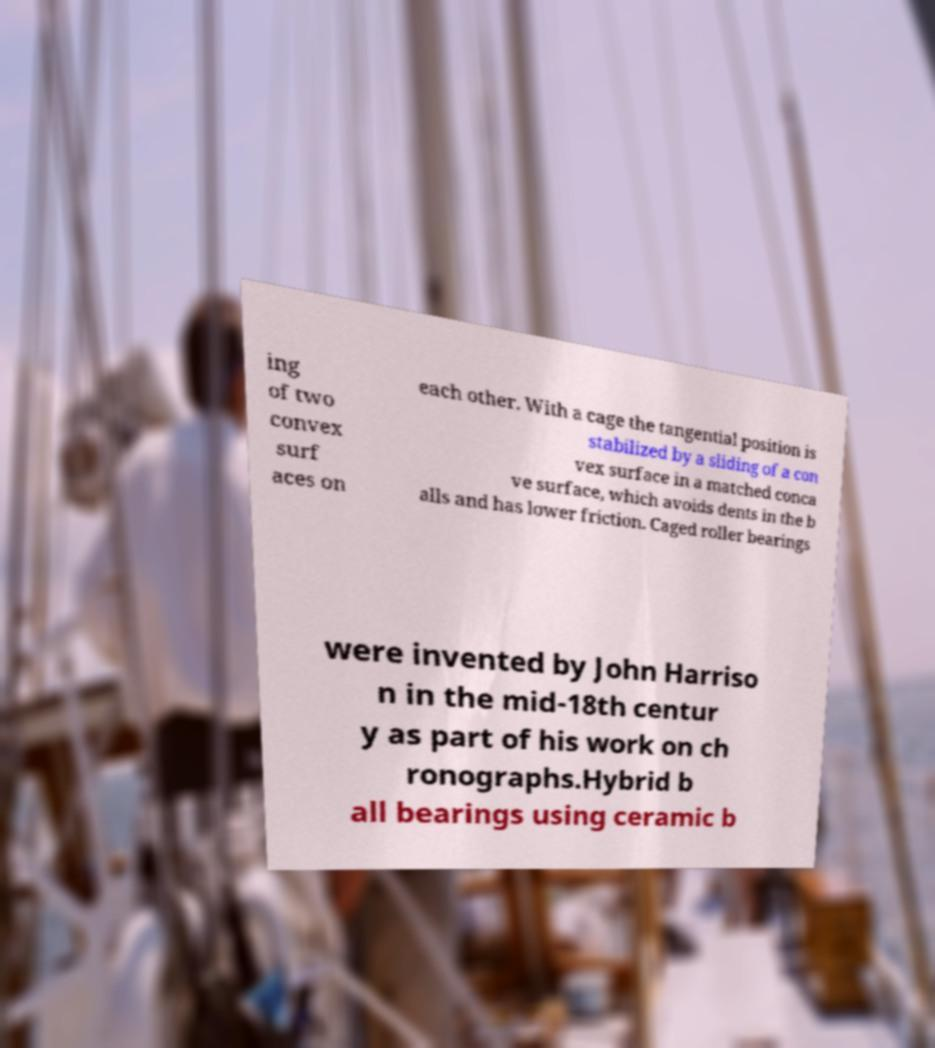For documentation purposes, I need the text within this image transcribed. Could you provide that? ing of two convex surf aces on each other. With a cage the tangential position is stabilized by a sliding of a con vex surface in a matched conca ve surface, which avoids dents in the b alls and has lower friction. Caged roller bearings were invented by John Harriso n in the mid-18th centur y as part of his work on ch ronographs.Hybrid b all bearings using ceramic b 